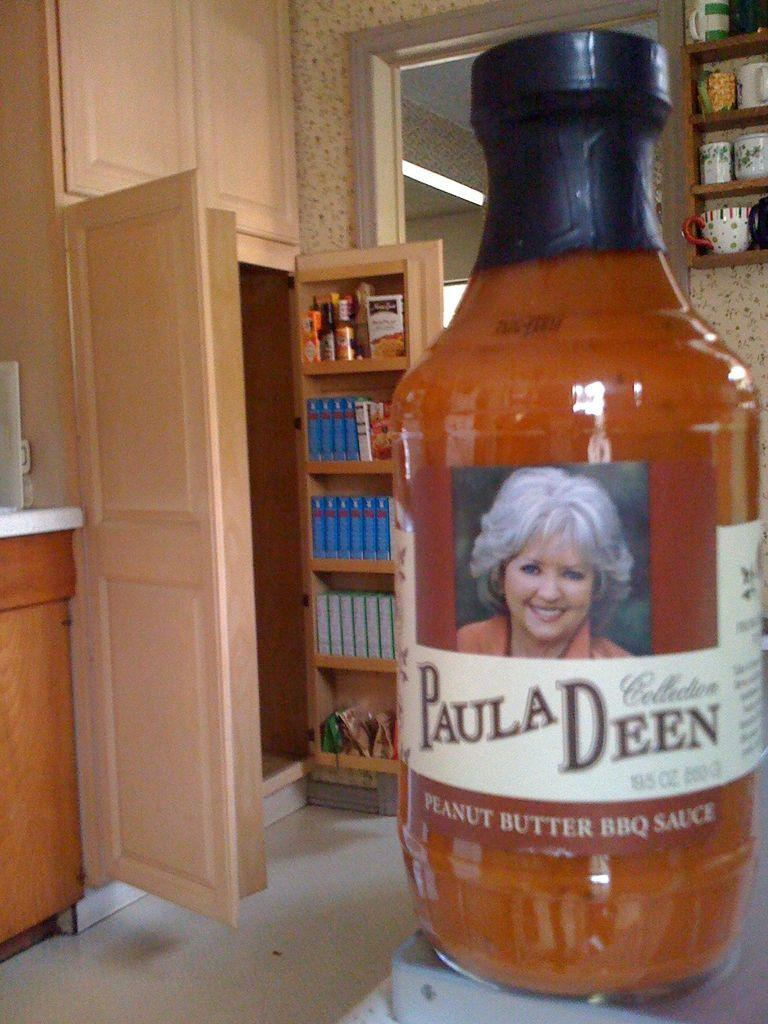<image>
Give a short and clear explanation of the subsequent image. A bottle of Paula Deen Peanut Butter BBQ Sauce. 